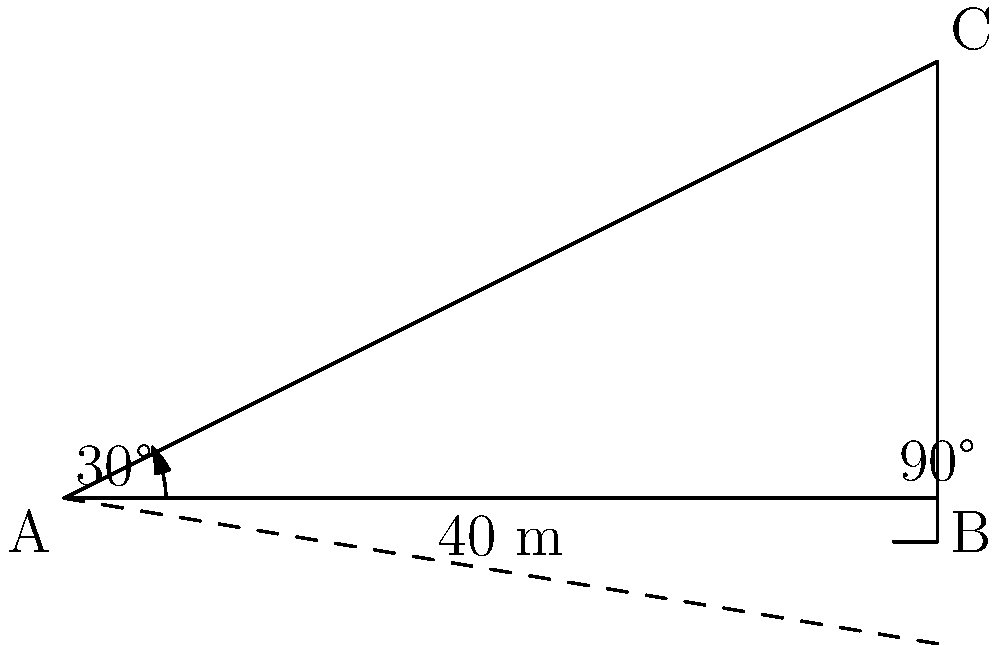An archaeologist is studying an ancient Egyptian pyramid. From a point on the ground, the angle of elevation to the top of the pyramid is 30°. If the shadow of the pyramid extends 40 meters from its base, what is the height of the pyramid? Round your answer to the nearest meter. Let's approach this step-by-step:

1) We can use the trigonometric ratio tangent (tan) to solve this problem. The tangent of an angle in a right triangle is the ratio of the opposite side to the adjacent side.

2) In this case:
   - The angle of elevation is 30°
   - The adjacent side (shadow length) is 40 meters
   - We need to find the opposite side (height of the pyramid)

3) The formula we'll use is:

   $\tan(\theta) = \frac{\text{opposite}}{\text{adjacent}}$

4) Plugging in our known values:

   $\tan(30°) = \frac{\text{height}}{40}$

5) We know that $\tan(30°) = \frac{1}{\sqrt{3}} \approx 0.5774$

6) So our equation becomes:

   $0.5774 = \frac{\text{height}}{40}$

7) To solve for the height, we multiply both sides by 40:

   $\text{height} = 0.5774 \times 40 = 23.096$ meters

8) Rounding to the nearest meter:

   $\text{height} \approx 23$ meters
Answer: 23 meters 